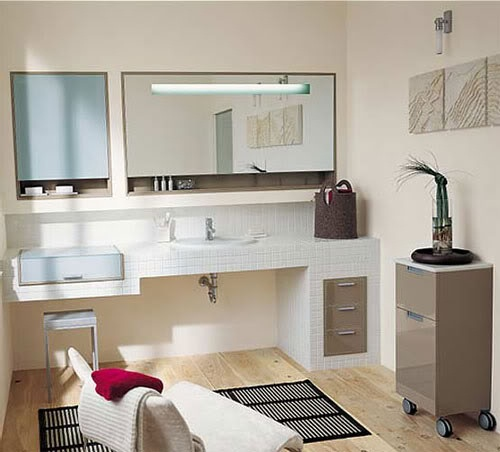Describe the objects in this image and their specific colors. I can see potted plant in tan, lightgray, gray, black, and darkgray tones, handbag in tan, black, and gray tones, and sink in tan, lightgray, and darkgray tones in this image. 